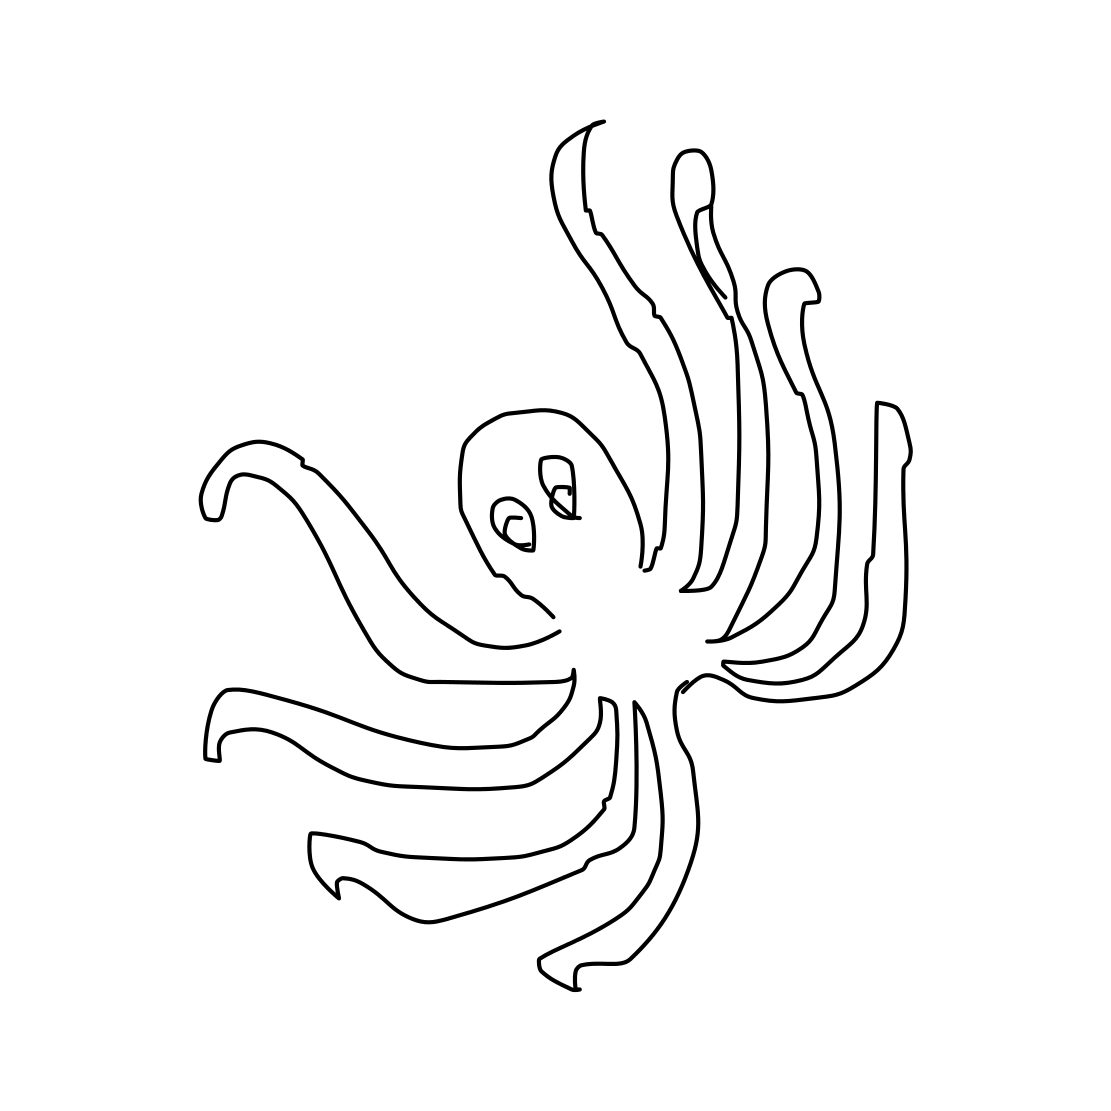Could you tell me a fun fact about octopuses? Certainly! Octopuses are highly intelligent creatures known for their problem-solving abilities. They can change color and texture to blend into their surroundings, making them masters of camouflage. 